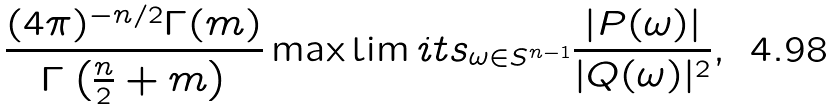<formula> <loc_0><loc_0><loc_500><loc_500>\frac { ( 4 \pi ) ^ { - n / 2 } \Gamma ( m ) } { \Gamma \left ( \frac { n } { 2 } + m \right ) } \max \lim i t s _ { \omega \in S ^ { n - 1 } } \frac { | P ( \omega ) | } { | Q ( \omega ) | ^ { 2 } } ,</formula> 